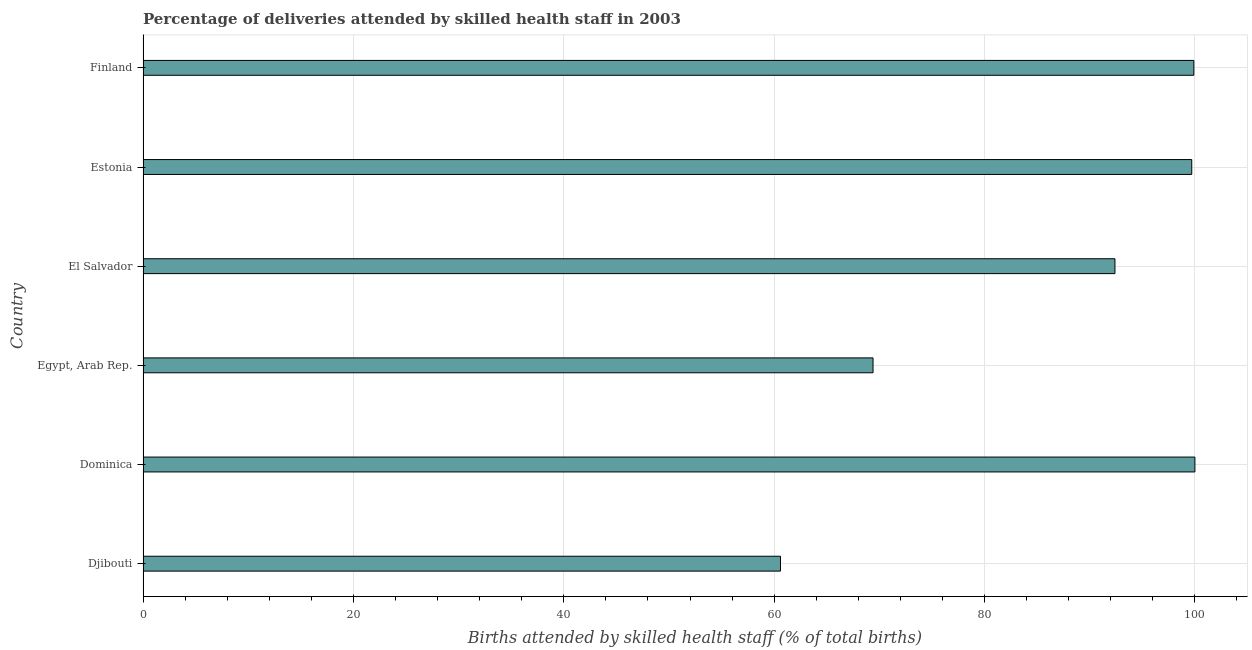Does the graph contain grids?
Keep it short and to the point. Yes. What is the title of the graph?
Your answer should be very brief. Percentage of deliveries attended by skilled health staff in 2003. What is the label or title of the X-axis?
Give a very brief answer. Births attended by skilled health staff (% of total births). What is the label or title of the Y-axis?
Offer a terse response. Country. What is the number of births attended by skilled health staff in Estonia?
Ensure brevity in your answer.  99.7. Across all countries, what is the maximum number of births attended by skilled health staff?
Give a very brief answer. 100. Across all countries, what is the minimum number of births attended by skilled health staff?
Your answer should be compact. 60.6. In which country was the number of births attended by skilled health staff maximum?
Provide a short and direct response. Dominica. In which country was the number of births attended by skilled health staff minimum?
Offer a terse response. Djibouti. What is the sum of the number of births attended by skilled health staff?
Make the answer very short. 522. What is the difference between the number of births attended by skilled health staff in Dominica and Finland?
Provide a succinct answer. 0.1. What is the median number of births attended by skilled health staff?
Your answer should be very brief. 96.05. Is the sum of the number of births attended by skilled health staff in Djibouti and El Salvador greater than the maximum number of births attended by skilled health staff across all countries?
Provide a succinct answer. Yes. What is the difference between the highest and the lowest number of births attended by skilled health staff?
Your answer should be very brief. 39.4. How many countries are there in the graph?
Your response must be concise. 6. What is the Births attended by skilled health staff (% of total births) in Djibouti?
Offer a very short reply. 60.6. What is the Births attended by skilled health staff (% of total births) in Egypt, Arab Rep.?
Offer a terse response. 69.4. What is the Births attended by skilled health staff (% of total births) of El Salvador?
Make the answer very short. 92.4. What is the Births attended by skilled health staff (% of total births) in Estonia?
Your answer should be compact. 99.7. What is the Births attended by skilled health staff (% of total births) in Finland?
Give a very brief answer. 99.9. What is the difference between the Births attended by skilled health staff (% of total births) in Djibouti and Dominica?
Ensure brevity in your answer.  -39.4. What is the difference between the Births attended by skilled health staff (% of total births) in Djibouti and El Salvador?
Your answer should be compact. -31.8. What is the difference between the Births attended by skilled health staff (% of total births) in Djibouti and Estonia?
Offer a terse response. -39.1. What is the difference between the Births attended by skilled health staff (% of total births) in Djibouti and Finland?
Offer a very short reply. -39.3. What is the difference between the Births attended by skilled health staff (% of total births) in Dominica and Egypt, Arab Rep.?
Your response must be concise. 30.6. What is the difference between the Births attended by skilled health staff (% of total births) in Dominica and El Salvador?
Offer a terse response. 7.6. What is the difference between the Births attended by skilled health staff (% of total births) in Dominica and Finland?
Your answer should be compact. 0.1. What is the difference between the Births attended by skilled health staff (% of total births) in Egypt, Arab Rep. and Estonia?
Keep it short and to the point. -30.3. What is the difference between the Births attended by skilled health staff (% of total births) in Egypt, Arab Rep. and Finland?
Make the answer very short. -30.5. What is the difference between the Births attended by skilled health staff (% of total births) in El Salvador and Estonia?
Give a very brief answer. -7.3. What is the difference between the Births attended by skilled health staff (% of total births) in El Salvador and Finland?
Offer a very short reply. -7.5. What is the difference between the Births attended by skilled health staff (% of total births) in Estonia and Finland?
Your answer should be very brief. -0.2. What is the ratio of the Births attended by skilled health staff (% of total births) in Djibouti to that in Dominica?
Provide a succinct answer. 0.61. What is the ratio of the Births attended by skilled health staff (% of total births) in Djibouti to that in Egypt, Arab Rep.?
Offer a terse response. 0.87. What is the ratio of the Births attended by skilled health staff (% of total births) in Djibouti to that in El Salvador?
Your answer should be compact. 0.66. What is the ratio of the Births attended by skilled health staff (% of total births) in Djibouti to that in Estonia?
Provide a succinct answer. 0.61. What is the ratio of the Births attended by skilled health staff (% of total births) in Djibouti to that in Finland?
Your response must be concise. 0.61. What is the ratio of the Births attended by skilled health staff (% of total births) in Dominica to that in Egypt, Arab Rep.?
Your response must be concise. 1.44. What is the ratio of the Births attended by skilled health staff (% of total births) in Dominica to that in El Salvador?
Provide a short and direct response. 1.08. What is the ratio of the Births attended by skilled health staff (% of total births) in Dominica to that in Finland?
Your response must be concise. 1. What is the ratio of the Births attended by skilled health staff (% of total births) in Egypt, Arab Rep. to that in El Salvador?
Provide a succinct answer. 0.75. What is the ratio of the Births attended by skilled health staff (% of total births) in Egypt, Arab Rep. to that in Estonia?
Your response must be concise. 0.7. What is the ratio of the Births attended by skilled health staff (% of total births) in Egypt, Arab Rep. to that in Finland?
Provide a succinct answer. 0.69. What is the ratio of the Births attended by skilled health staff (% of total births) in El Salvador to that in Estonia?
Keep it short and to the point. 0.93. What is the ratio of the Births attended by skilled health staff (% of total births) in El Salvador to that in Finland?
Keep it short and to the point. 0.93. 